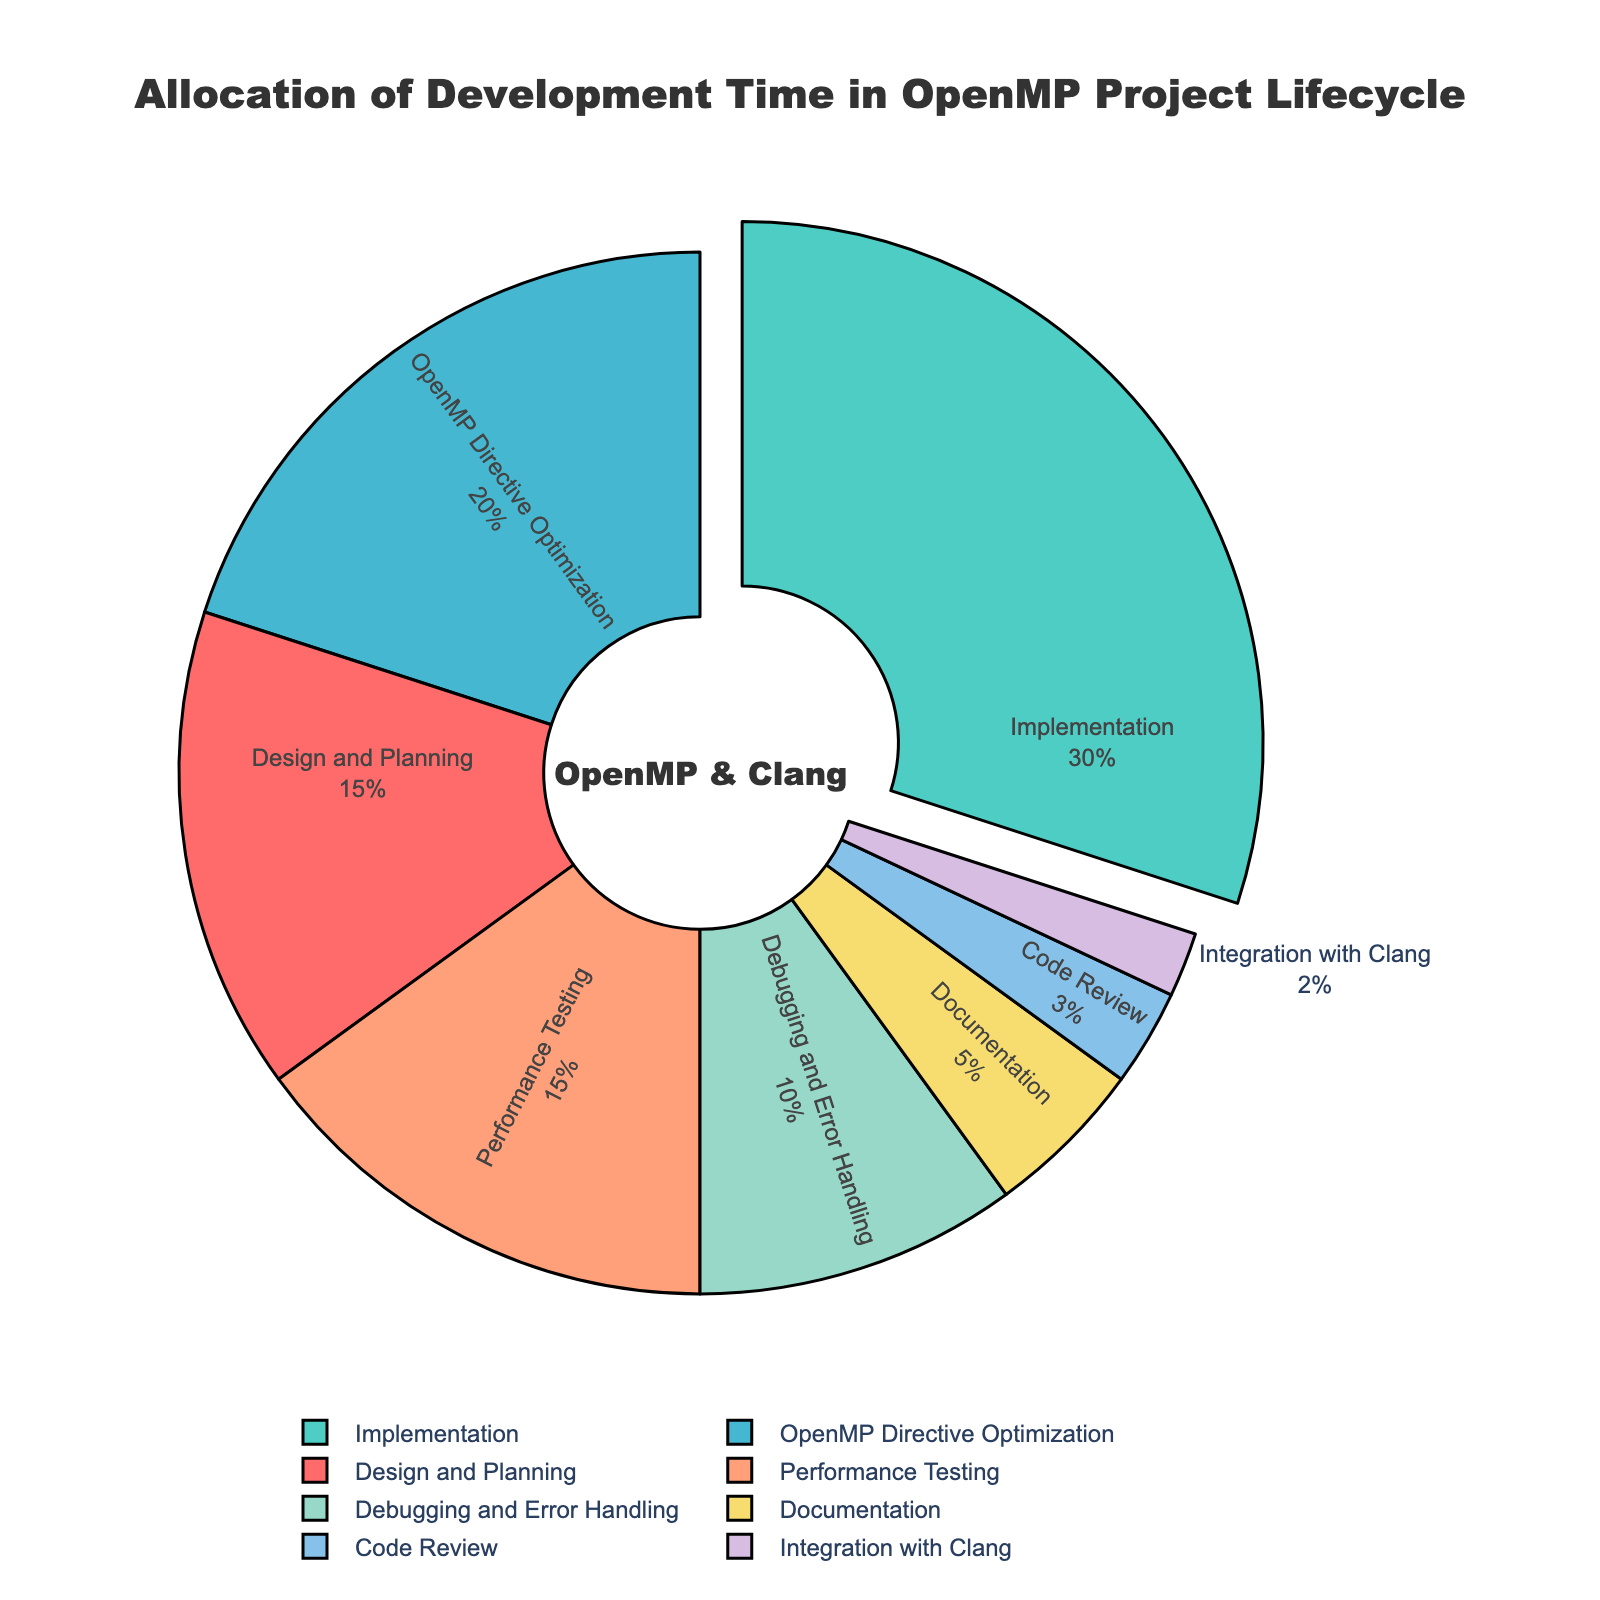What phase takes up the largest proportion of development time? The pie chart highlights the largest proportion by pulling that particular segment outward. The segment labeled "Implementation" is pulled out and constitutes 30% of the total.
Answer: Implementation Which phases together have a combined percentage of 30%? By looking at the pie chart, the segments labeled "Design and Planning" (15%) and "Performance Testing" (15%) together make up a combined total of 30%.
Answer: Design and Planning, Performance Testing How much more time is allocated to Implementation compared to Debugging and Error Handling? The "Implementation" phase accounts for 30%, while "Debugging and Error Handling" occupies 10%. The difference between these two is 30% - 10% = 20%.
Answer: 20% Which phases have been allocated 15% of development time each? The pie chart shows that "Design and Planning" and "Performance Testing" segments each occupy 15% of the total development time.
Answer: Design and Planning, Performance Testing What is the total percentage allocated to OpenMP Directive Optimization, Code Review, and Documentation combined? OpenMP Directive Optimization (20%), Code Review (3%), and Documentation (5%) together sum up to 20% + 3% + 5% = 28%.
Answer: 28% Is the time allocated to Integration with Clang greater than that allocated to Code Review? The pie chart shows that "Integration with Clang" has 2% while "Code Review" has 3%, thus 3% > 2%.
Answer: No Which segment has the least allocated time and what is its percentage? The smallest segment within the pie chart is labeled "Integration with Clang" and it accounts for 2%.
Answer: Integration with Clang, 2% Describe the visual style used to highlight the largest segment in the pie chart. The largest segment in the pie chart, labeled "Implementation," is visually highlighted by being slightly pulled away from the center of the pie chart, making it more prominent.
Answer: Pulled out segment What is the combined percentage of phases that directly involve code changes? The phases "Implementation" (30%), "OpenMP Directive Optimization" (20%), and "Debugging and Error Handling" (10%) directly involve code changes, giving a total of 30% + 20% + 10% = 60%.
Answer: 60% How much more time in percentage is allocated to Performance Testing compared to Documentation? The pie chart shows "Performance Testing" has 15% and "Documentation" has 5%. The difference is 15% - 5% = 10%.
Answer: 10% 